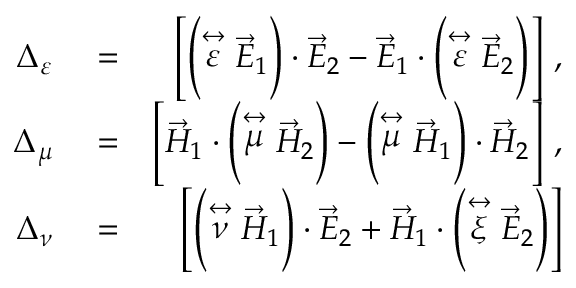<formula> <loc_0><loc_0><loc_500><loc_500>\begin{array} { r l r } { \Delta _ { \varepsilon } } & = } & { \left [ \left ( \stackrel { \leftrightarrow } { \varepsilon } \vec { E } _ { 1 } \right ) \cdot \vec { E } _ { 2 } - \vec { E } _ { 1 } \cdot \left ( \stackrel { \leftrightarrow } { \varepsilon } \vec { E } _ { 2 } \right ) \right ] \, , } \\ { \Delta _ { \mu } } & = } & { \left [ \vec { H } _ { 1 } \cdot \left ( \stackrel { \leftrightarrow } { \mu } \vec { H } _ { 2 } \right ) - \left ( \stackrel { \leftrightarrow } { \mu } \vec { H } _ { 1 } \right ) \cdot \vec { H } _ { 2 } \right ] \, , } \\ { \Delta _ { \nu } } & = } & { \left [ \left ( \stackrel { \leftrightarrow } { \nu } \vec { H } _ { 1 } \right ) \cdot \vec { E } _ { 2 } + \vec { H } _ { 1 } \cdot \left ( \stackrel { \leftrightarrow } { \xi } \vec { E } _ { 2 } \right ) \right ] } \end{array}</formula> 